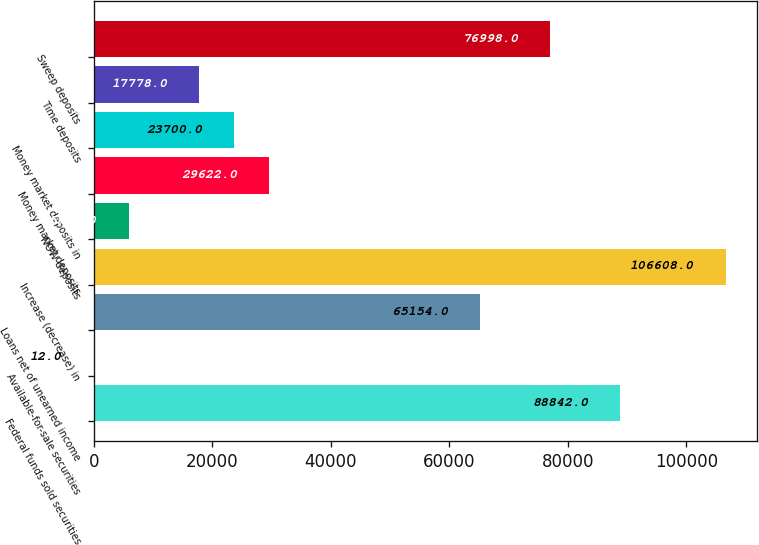<chart> <loc_0><loc_0><loc_500><loc_500><bar_chart><fcel>Federal funds sold securities<fcel>Available-for-sale securities<fcel>Loans net of unearned income<fcel>Increase (decrease) in<fcel>NOW deposits<fcel>Money market deposits<fcel>Money market deposits in<fcel>Time deposits<fcel>Sweep deposits<nl><fcel>88842<fcel>12<fcel>65154<fcel>106608<fcel>5934<fcel>29622<fcel>23700<fcel>17778<fcel>76998<nl></chart> 